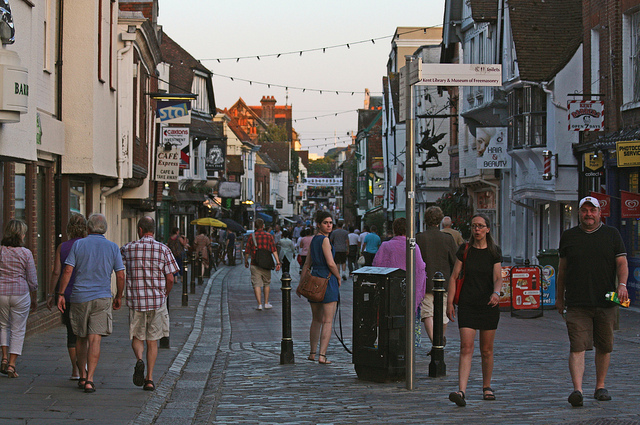What time of day does it appear to be in this image, and how can you tell? It appears to be late afternoon or early evening, as evidenced by the long shadows cast by the people and the warm, soft lighting. The sky has a golden hue, which is characteristic of the time shortly before sunset. 